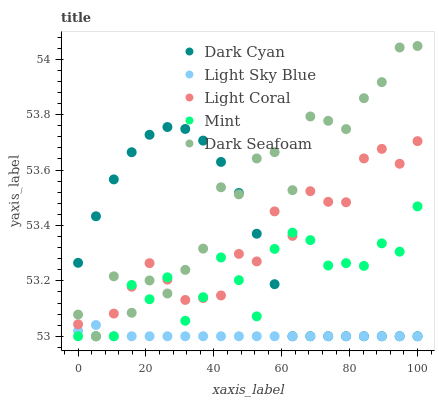Does Light Sky Blue have the minimum area under the curve?
Answer yes or no. Yes. Does Dark Seafoam have the maximum area under the curve?
Answer yes or no. Yes. Does Light Coral have the minimum area under the curve?
Answer yes or no. No. Does Light Coral have the maximum area under the curve?
Answer yes or no. No. Is Light Sky Blue the smoothest?
Answer yes or no. Yes. Is Dark Seafoam the roughest?
Answer yes or no. Yes. Is Light Coral the smoothest?
Answer yes or no. No. Is Light Coral the roughest?
Answer yes or no. No. Does Dark Cyan have the lowest value?
Answer yes or no. Yes. Does Dark Seafoam have the highest value?
Answer yes or no. Yes. Does Light Coral have the highest value?
Answer yes or no. No. Does Dark Cyan intersect Mint?
Answer yes or no. Yes. Is Dark Cyan less than Mint?
Answer yes or no. No. Is Dark Cyan greater than Mint?
Answer yes or no. No. 